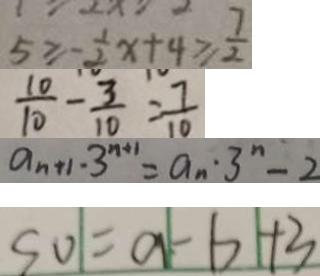Convert formula to latex. <formula><loc_0><loc_0><loc_500><loc_500>5 \geq - \frac { 1 } { 2 } x + 4 \geq \frac { 7 } { 2 } 
 \frac { 1 0 } { 1 0 } - \frac { 3 } { 1 0 } = \frac { 7 } { 1 0 } 
 a _ { n + 1 } \cdot 3 ^ { n + 1 } = a _ { n } \cdot 3 ^ { n } - 2 
 S O = a - b + 3</formula> 